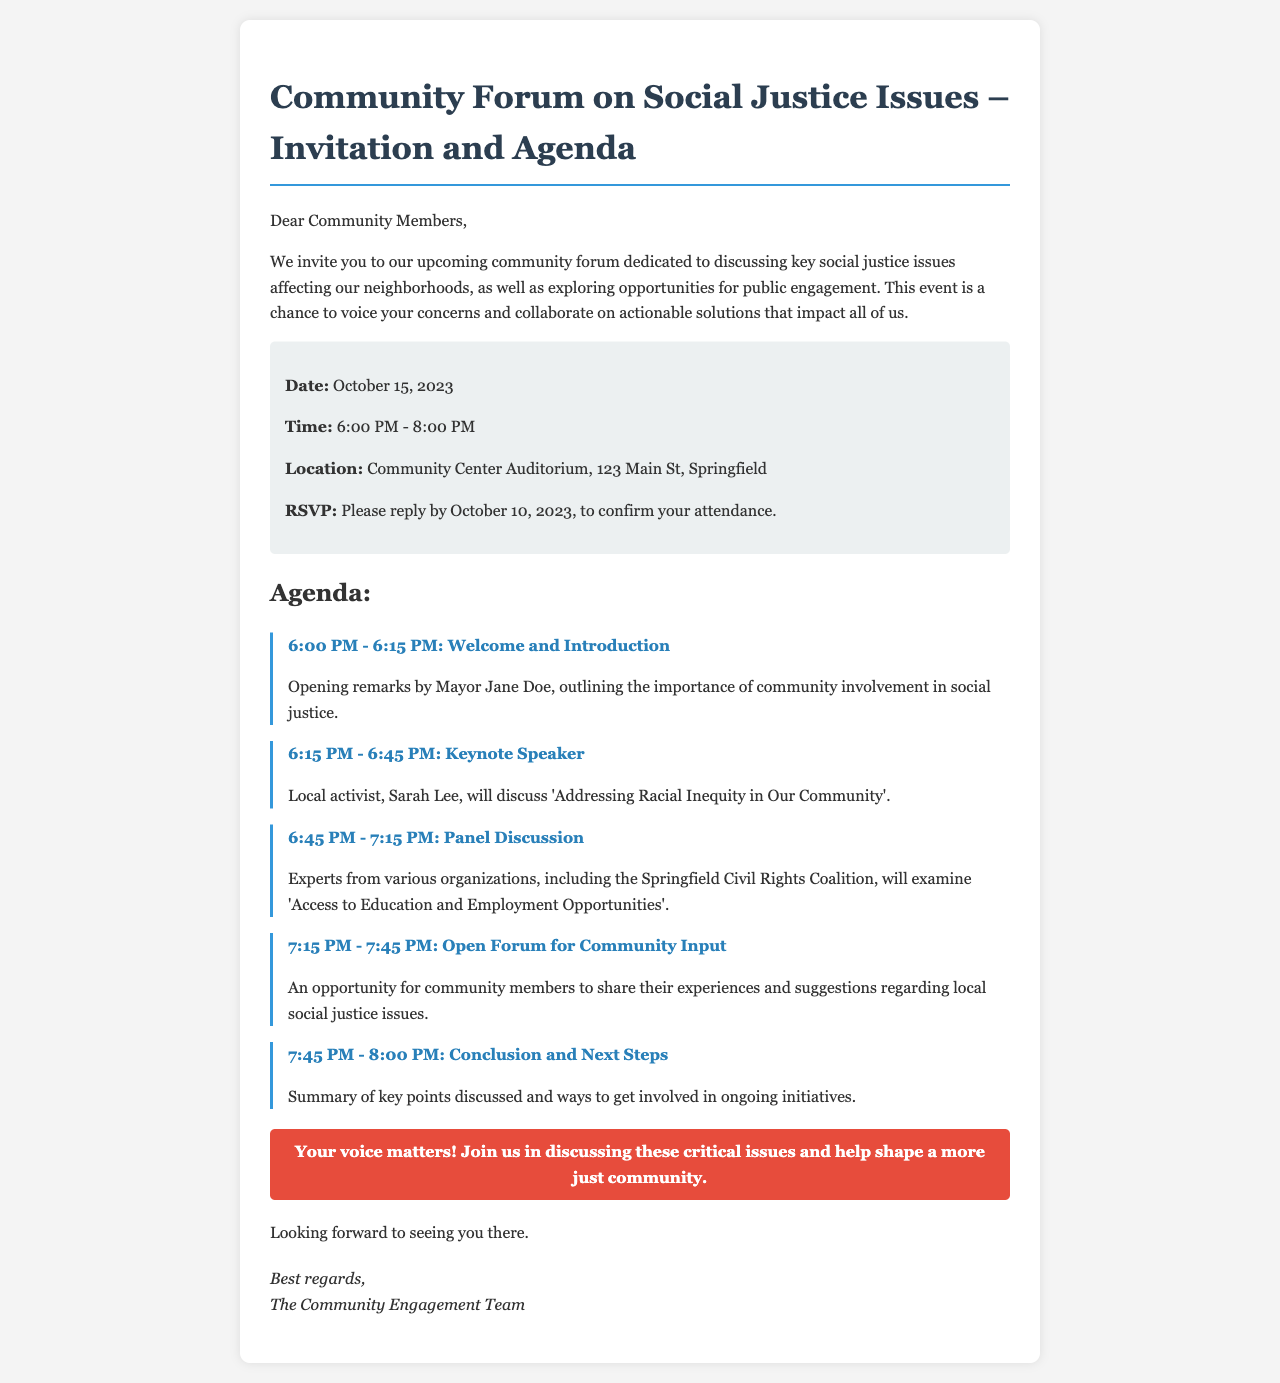What is the date of the forum? The date of the forum is explicitly stated in the document.
Answer: October 15, 2023 What time does the forum start? The starting time of the forum is mentioned in the event details section of the document.
Answer: 6:00 PM Who is the keynote speaker? The name of the keynote speaker is given in the agenda section of the document.
Answer: Sarah Lee What topic will the keynote speaker discuss? The topic of the keynote address is specified right after the speaker's name in the agenda.
Answer: Addressing Racial Inequity in Our Community How long is the open forum for community input? The duration of the open forum is indicated in the agenda section of the document.
Answer: 30 minutes What organization is mentioned in the panel discussion? The organization involved in the panel discussion is listed in the discussion description.
Answer: Springfield Civil Rights Coalition What is the purpose of the community forum? The purpose of the forum is stated in the introduction paragraph, outlining its significance.
Answer: Discussing key social justice issues When is the RSVP deadline? The RSVP deadline is part of the event details section and specifies when attendees must confirm their participation.
Answer: October 10, 2023 What will happen at 7:45 PM? The agenda outlines the concluding activity scheduled for that time.
Answer: Conclusion and Next Steps 